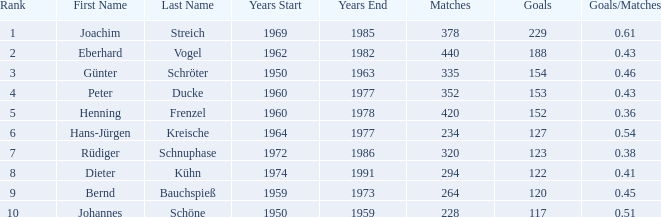What are the lowest goal that have goals/matches greater than 0.43 with joachim streich as the name and matches greater than 378? None. 